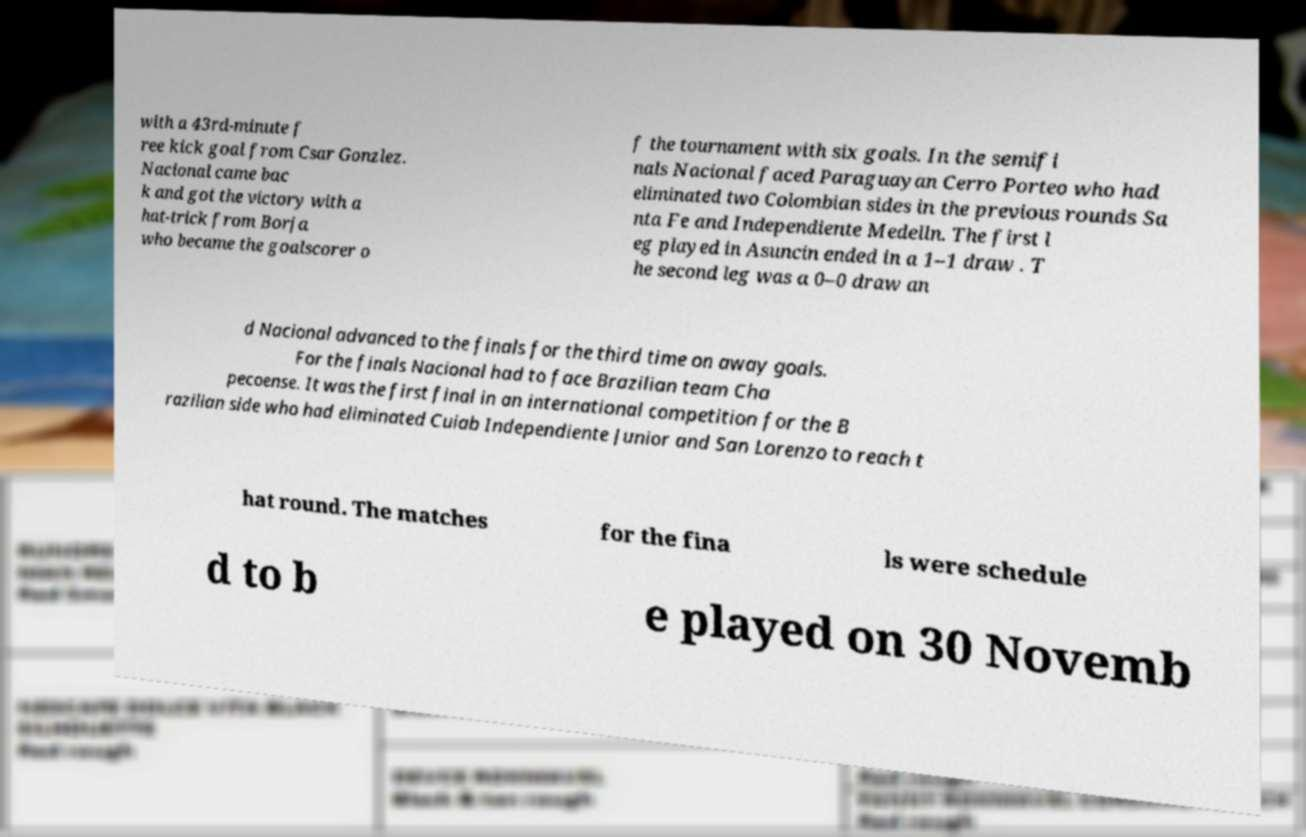Can you accurately transcribe the text from the provided image for me? with a 43rd-minute f ree kick goal from Csar Gonzlez. Nacional came bac k and got the victory with a hat-trick from Borja who became the goalscorer o f the tournament with six goals. In the semifi nals Nacional faced Paraguayan Cerro Porteo who had eliminated two Colombian sides in the previous rounds Sa nta Fe and Independiente Medelln. The first l eg played in Asuncin ended in a 1–1 draw . T he second leg was a 0–0 draw an d Nacional advanced to the finals for the third time on away goals. For the finals Nacional had to face Brazilian team Cha pecoense. It was the first final in an international competition for the B razilian side who had eliminated Cuiab Independiente Junior and San Lorenzo to reach t hat round. The matches for the fina ls were schedule d to b e played on 30 Novemb 